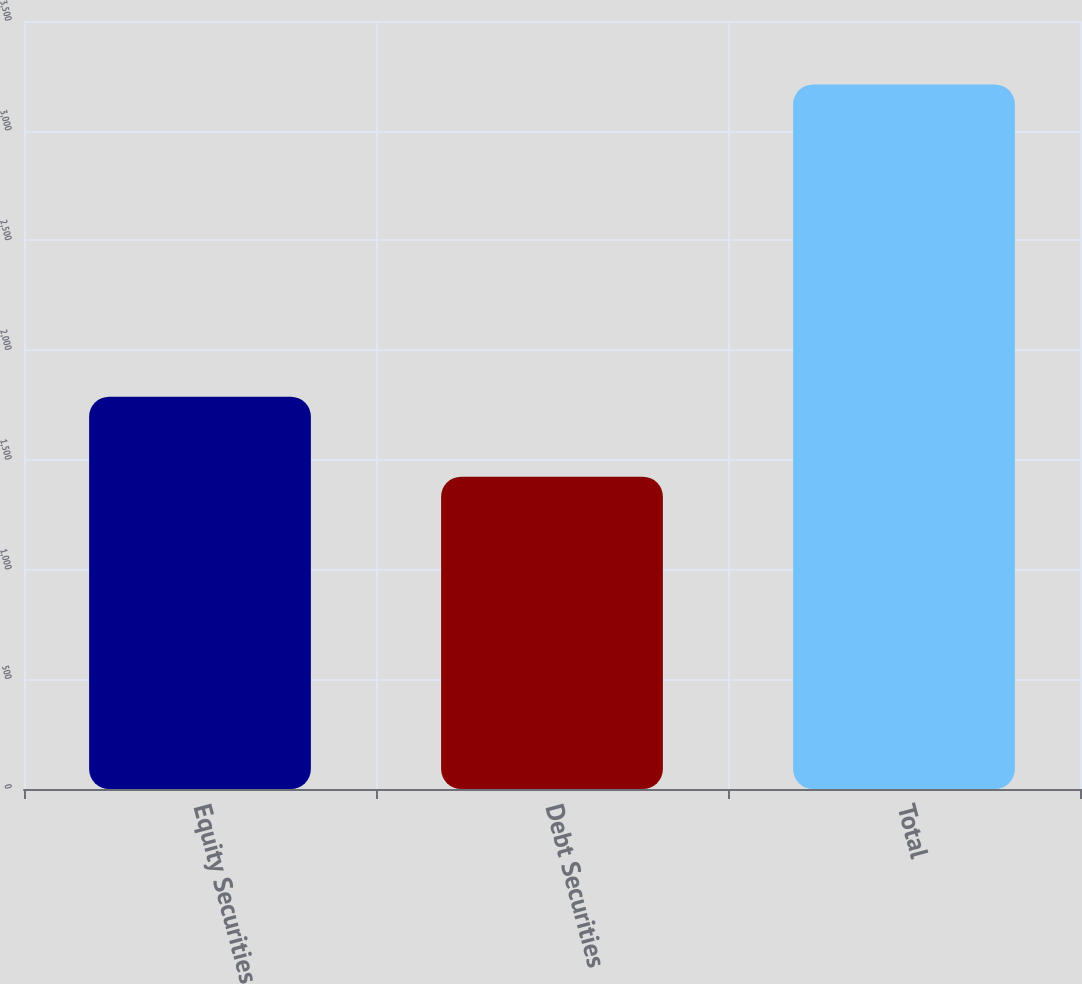<chart> <loc_0><loc_0><loc_500><loc_500><bar_chart><fcel>Equity Securities<fcel>Debt Securities<fcel>Total<nl><fcel>1788<fcel>1423<fcel>3211<nl></chart> 